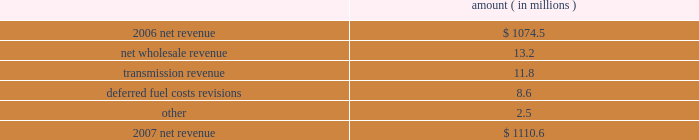Entergy arkansas , inc .
Management's financial discussion and analysis gross operating revenues and fuel and purchased power expenses gross operating revenues increased primarily due to : an increase of $ 114 million in gross wholesale revenue due to an increase in the average price of energy available for resale sales and an increase in sales to affiliated customers ; an increase of $ 106.1 million in production cost allocation rider revenues which became effective in july 2007 as a result of the system agreement proceedings .
As a result of the system agreement proceedings , entergy arkansas also has a corresponding increase in deferred fuel expense for payments to other entergy system companies such that there is no effect on net income .
Entergy arkansas makes payments over a seven-month period but collections from customers occur over a twelve-month period .
The production cost allocation rider is discussed in note 2 to the financial statements and the system agreement proceedings are referenced below under "federal regulation" ; and an increase of $ 58.9 million in fuel cost recovery revenues due to changes in the energy cost recovery rider effective april 2008 and september 2008 , partially offset by decreased usage .
The energy cost recovery rider filings are discussed in note 2 to the financial statements .
The increase was partially offset by a decrease of $ 14.6 million related to volume/weather , as discussed above .
Fuel and purchased power expenses increased primarily due to an increase of $ 106.1 million in deferred system agreement payments , as discussed above and an increase in the average market price of purchased power .
2007 compared to 2006 net revenue consists of operating revenues net of : 1 ) fuel , fuel-related expenses , and gas purchased for resale , 2 ) purchased power expenses , and 3 ) other regulatory credits .
Following is an analysis of the change in net revenue comparing 2007 to 2006 .
Amount ( in millions ) .
The net wholesale revenue variance is primarily due to lower wholesale revenues in the third quarter 2006 due to an october 2006 ferc order requiring entergy arkansas to make a refund to a coal plant co-owner resulting from a contract dispute , in addition to re-pricing revisions , retroactive to 2003 , of $ 5.9 million of purchased power agreements among entergy system companies as directed by the ferc .
The transmission revenue variance is primarily due to higher rates and the addition of new transmission customers in late 2006 .
The deferred fuel cost revisions variance is primarily due to the 2006 energy cost recovery true-up , made in the first quarter 2007 , which increased net revenue by $ 6.6 million .
Gross operating revenue and fuel and purchased power expenses gross operating revenues decreased primarily due to a decrease of $ 173.1 million in fuel cost recovery revenues due to a decrease in the energy cost recovery rider effective april 2007 .
The energy cost recovery rider is discussed in note 2 to the financial statements .
The decrease was partially offset by production cost allocation rider revenues of $ 124.1 million that became effective in july 2007 as a result of the system agreement proceedings .
As .
What is the growth rate in net revenue in 2007 for entergy arkansas , inc.? 
Computations: ((1110.6 - 1074.5) / 1074.5)
Answer: 0.0336. 